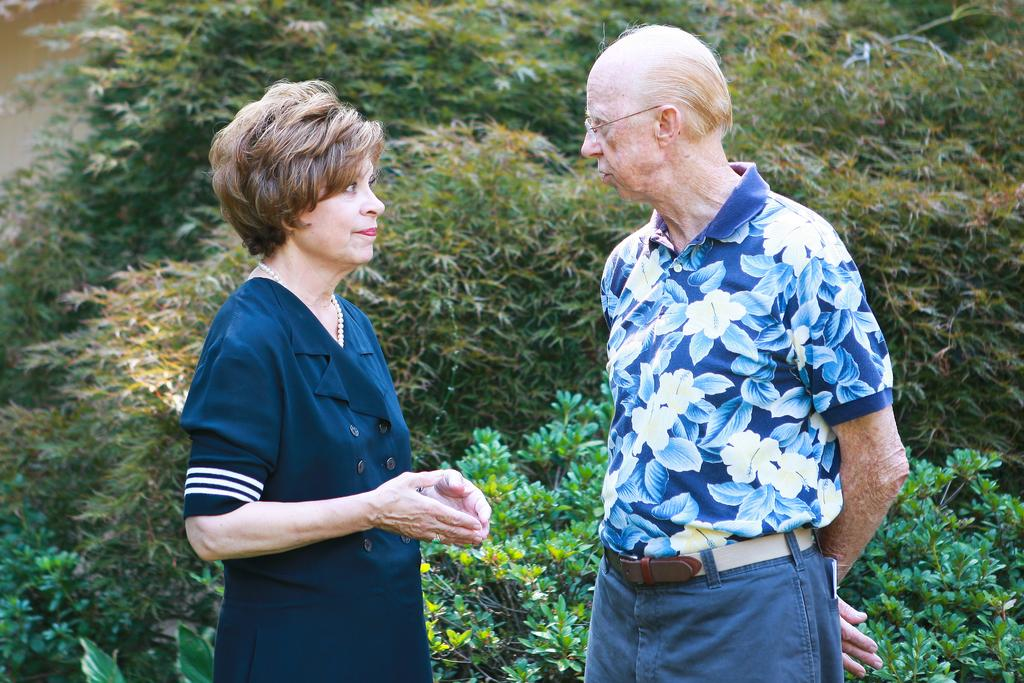Who are the people in the image? There is a woman and a man in the image. What are the woman and man doing in the image? The woman and man are looking at each other in the image. What position are the woman and man in? The woman and man are standing in the image. What can be seen in the background of the image? There are plants in the background of the image. Reasoning: To produce the conversation, we first identify the main subjects in the image, which are the woman and the man. We then describe their actions and positions, as well as the background elements. Each question is designed to elicit a specific detail about the image that is known from the provided facts. Absurd Question/Answer: What is the nightly income of the stick in the image? There is no stick present in the image, and therefore no income can be attributed to it. What type of stick can be seen in the image? There is no stick present in the image. What is the nightly income of the stick in the image? There is no stick present in the image, and therefore no income can be attributed to it. 